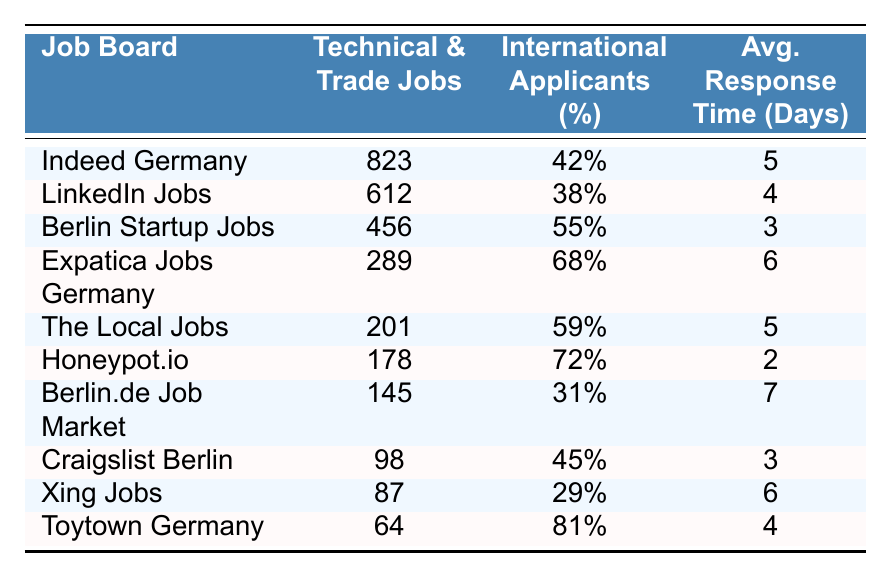What job board has the highest number of technical and trade job listings? By reviewing the table, Indeed Germany has 823 technical and trade job listings, which is the highest among all job boards listed.
Answer: Indeed Germany Which job board has the shortest average response time? The table shows Honeypot.io with an average response time of 2 days, making it the fastest in responding among the listed job boards.
Answer: Honeypot.io What is the average percentage of international applicants across these job boards? To find the average percentage, sum the percentages of international applicants: 42 + 38 + 55 + 68 + 59 + 72 + 31 + 45 + 29 + 81 = 420. Then, divide by the number of job boards (10): 420/10 = 42%.
Answer: 42% Is there any job board with more than 500 technical and trade job listings that also has a high percentage of international applicants? Yes, Indeed Germany and LinkedIn Jobs both have over 500 job listings, with international applicant percentages of 42% and 38%, respectively.
Answer: Yes What percentage of international applicants does Berlin.de Job Market have? According to the table, Berlin.de Job Market has a percentage of international applicants listed as 31%.
Answer: 31% Which job board has the highest percentage of international applicants? The table indicates that Toytown Germany has the highest percentage of international applicants at 81%.
Answer: Toytown Germany If we combine the job listings from Expatica Jobs Germany and The Local Jobs, how many technical and trade job listings would that yield? Adding the job listings: Expatica Jobs Germany has 289 listings and The Local Jobs has 201 listings. Therefore, 289 + 201 = 490.
Answer: 490 How many job listings are there across all job boards that have English language support? By summing all technical and trade job listings in the table: 823 + 612 + 456 + 289 + 201 + 178 + 145 + 98 + 87 + 64 = 1992.
Answer: 1992 Is there any job board listed that has more than 70% of international applicants and also has at least 100 technical job listings? Yes, Honeypot.io has 72% international applicants and 178 job listings, while Toytown Germany has 81% and 64 job listings, failing the listing condition, but Honeypot.io meets both conditions.
Answer: Yes What is the difference in technical job listings between Indeed Germany and Berlin.de Job Market? Indeed Germany has 823 listings and Berlin.de Job Market has 145 listings. The difference is 823 - 145 = 678.
Answer: 678 